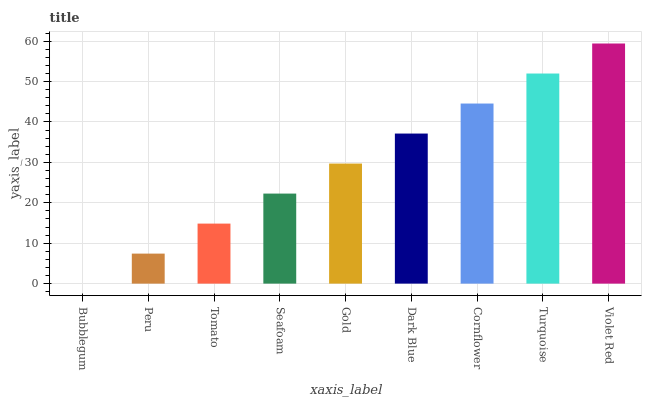Is Peru the minimum?
Answer yes or no. No. Is Peru the maximum?
Answer yes or no. No. Is Peru greater than Bubblegum?
Answer yes or no. Yes. Is Bubblegum less than Peru?
Answer yes or no. Yes. Is Bubblegum greater than Peru?
Answer yes or no. No. Is Peru less than Bubblegum?
Answer yes or no. No. Is Gold the high median?
Answer yes or no. Yes. Is Gold the low median?
Answer yes or no. Yes. Is Seafoam the high median?
Answer yes or no. No. Is Tomato the low median?
Answer yes or no. No. 